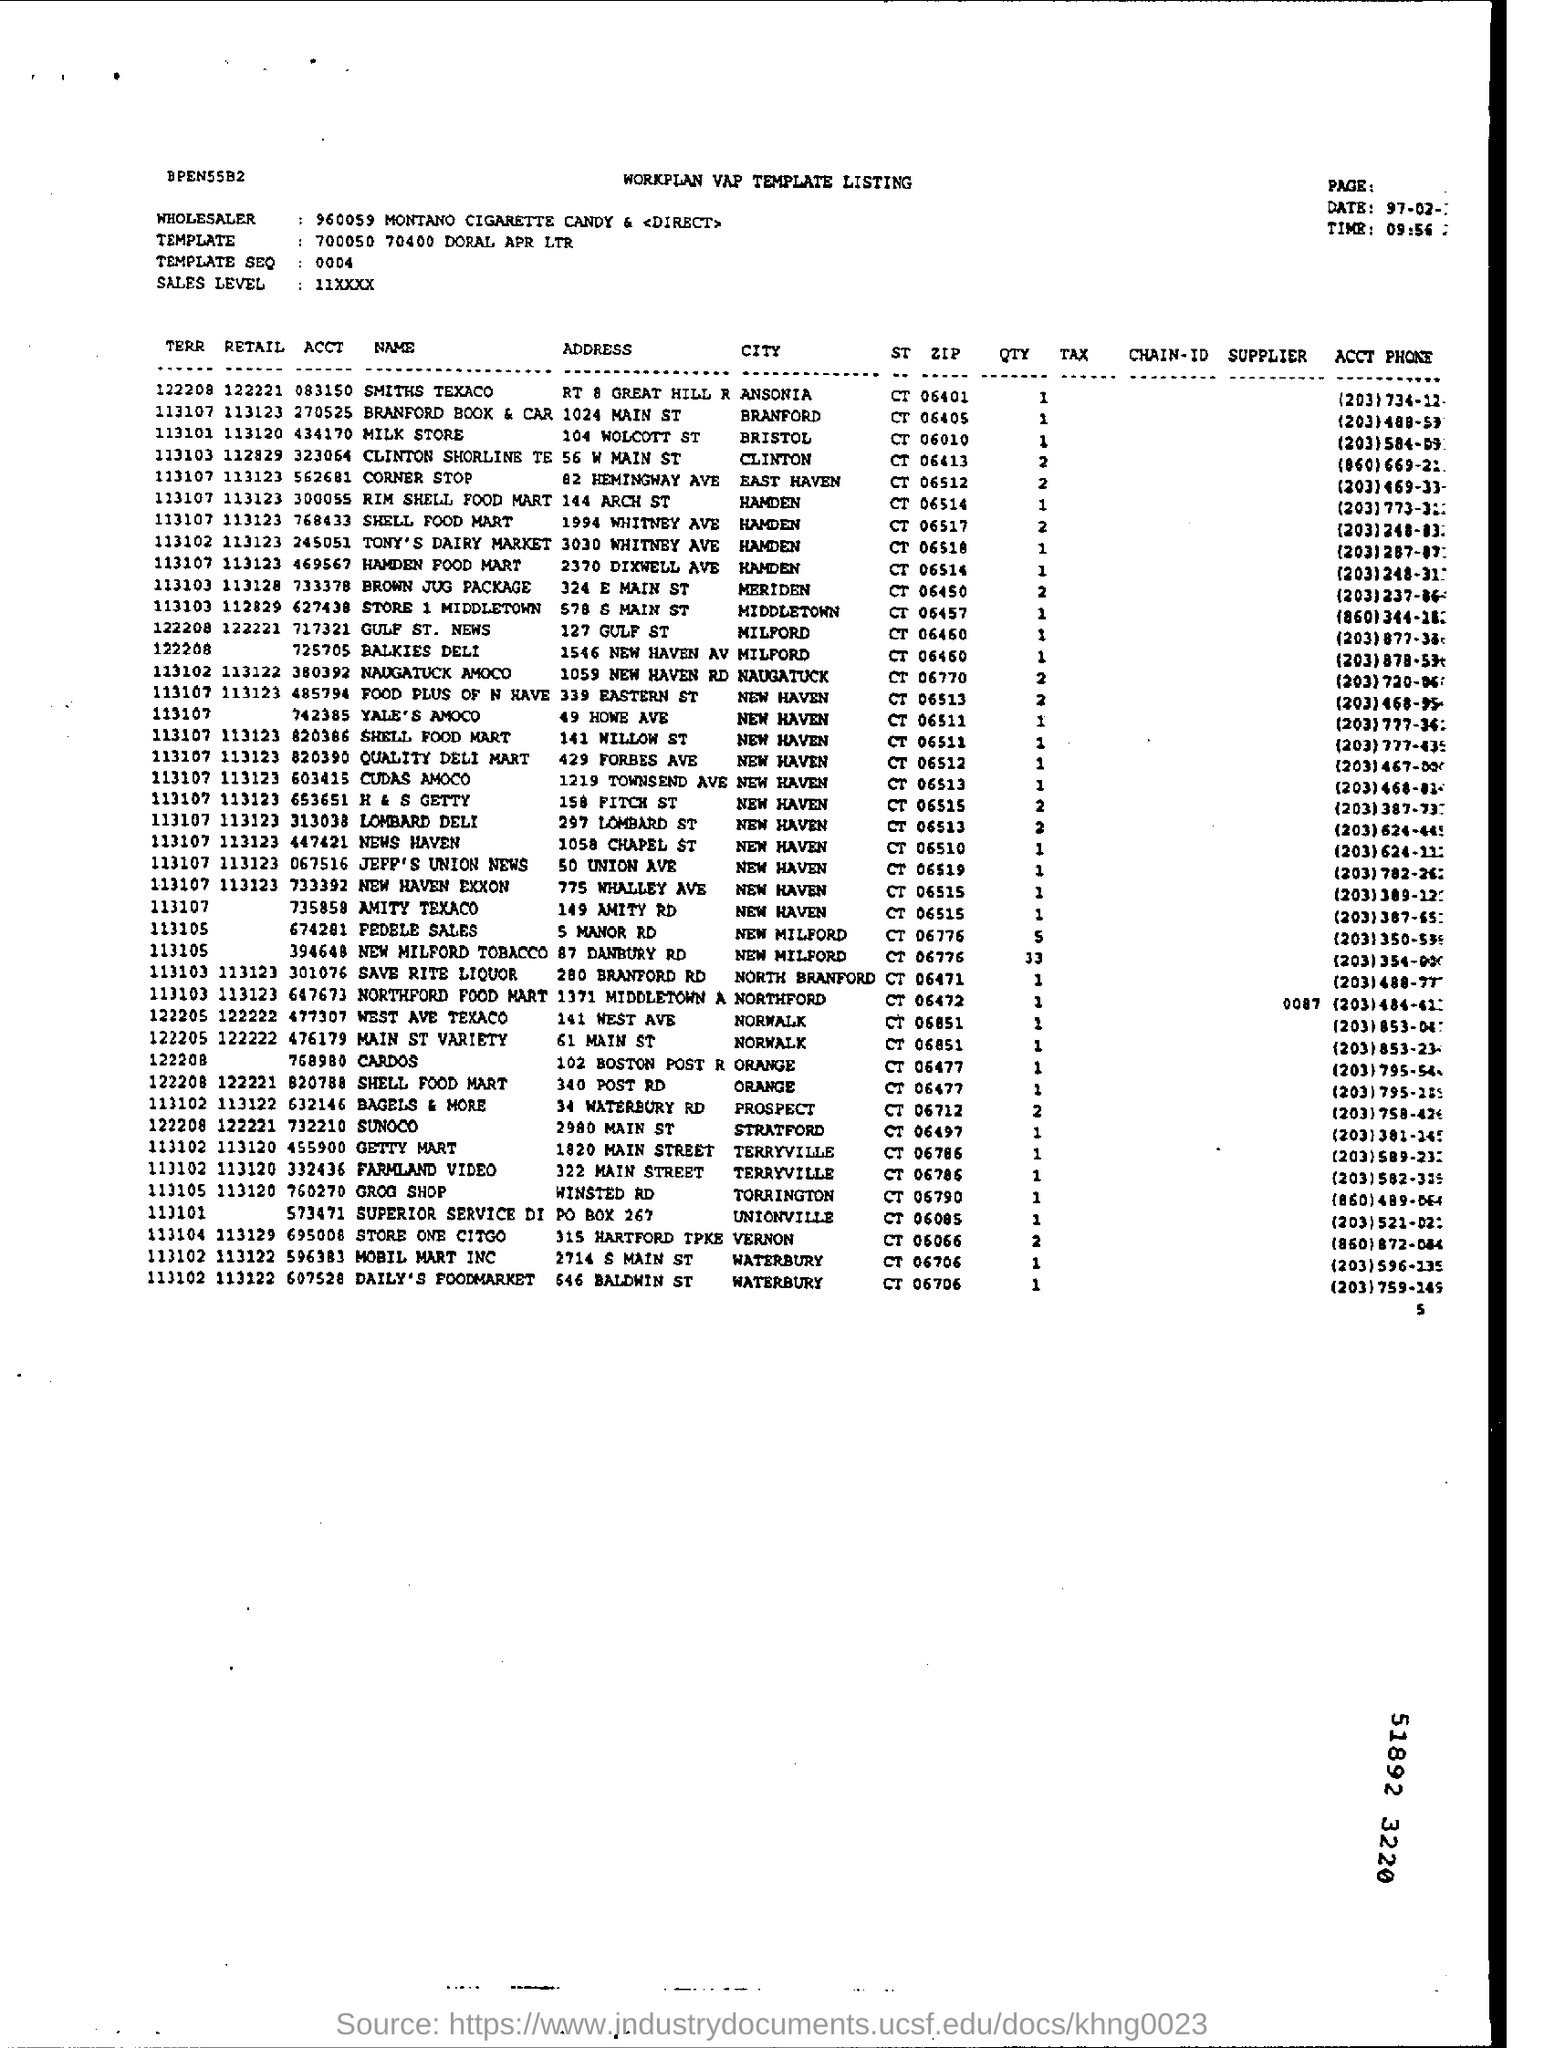Mention a couple of crucial points in this snapshot. The wholesaler's name is Montano Cigarette Candy & Tobacco Direct. What is the date mentioned? It is February 97. The address of SMITHS TEXACO is located at Route 8 Great Hill Road. What is the time mentioned to be 09:56...? This is a template that consists of the numbers 700050, 70400, and DORAL APR LTR. 